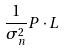Convert formula to latex. <formula><loc_0><loc_0><loc_500><loc_500>\frac { 1 } { \sigma _ { n } ^ { 2 } } P \cdot L</formula> 